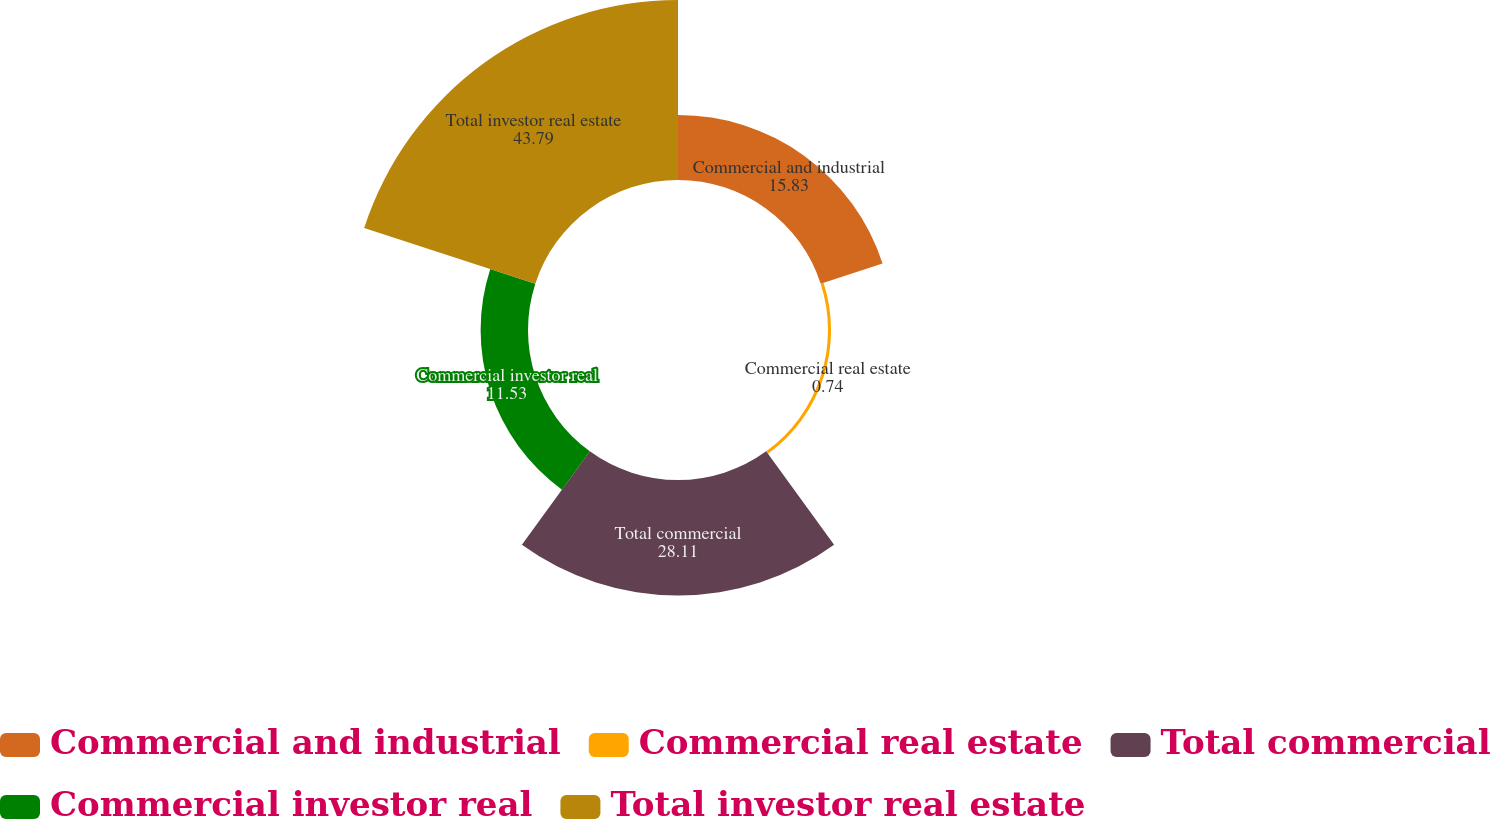<chart> <loc_0><loc_0><loc_500><loc_500><pie_chart><fcel>Commercial and industrial<fcel>Commercial real estate<fcel>Total commercial<fcel>Commercial investor real<fcel>Total investor real estate<nl><fcel>15.83%<fcel>0.74%<fcel>28.11%<fcel>11.53%<fcel>43.79%<nl></chart> 